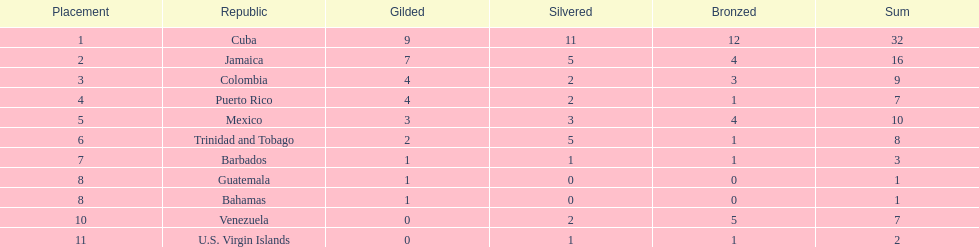Only team to have more than 30 medals Cuba. 